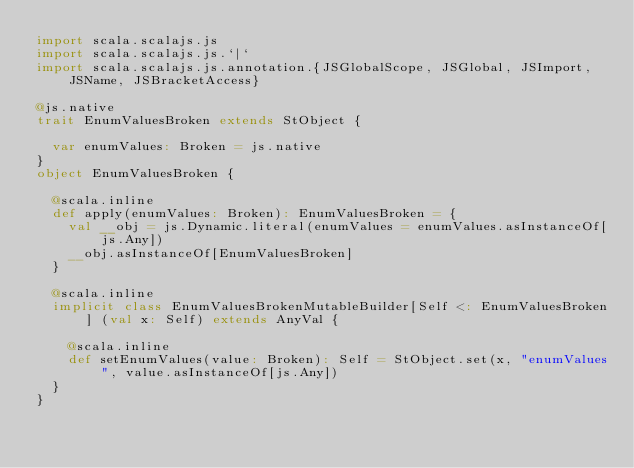<code> <loc_0><loc_0><loc_500><loc_500><_Scala_>import scala.scalajs.js
import scala.scalajs.js.`|`
import scala.scalajs.js.annotation.{JSGlobalScope, JSGlobal, JSImport, JSName, JSBracketAccess}

@js.native
trait EnumValuesBroken extends StObject {
  
  var enumValues: Broken = js.native
}
object EnumValuesBroken {
  
  @scala.inline
  def apply(enumValues: Broken): EnumValuesBroken = {
    val __obj = js.Dynamic.literal(enumValues = enumValues.asInstanceOf[js.Any])
    __obj.asInstanceOf[EnumValuesBroken]
  }
  
  @scala.inline
  implicit class EnumValuesBrokenMutableBuilder[Self <: EnumValuesBroken] (val x: Self) extends AnyVal {
    
    @scala.inline
    def setEnumValues(value: Broken): Self = StObject.set(x, "enumValues", value.asInstanceOf[js.Any])
  }
}
</code> 